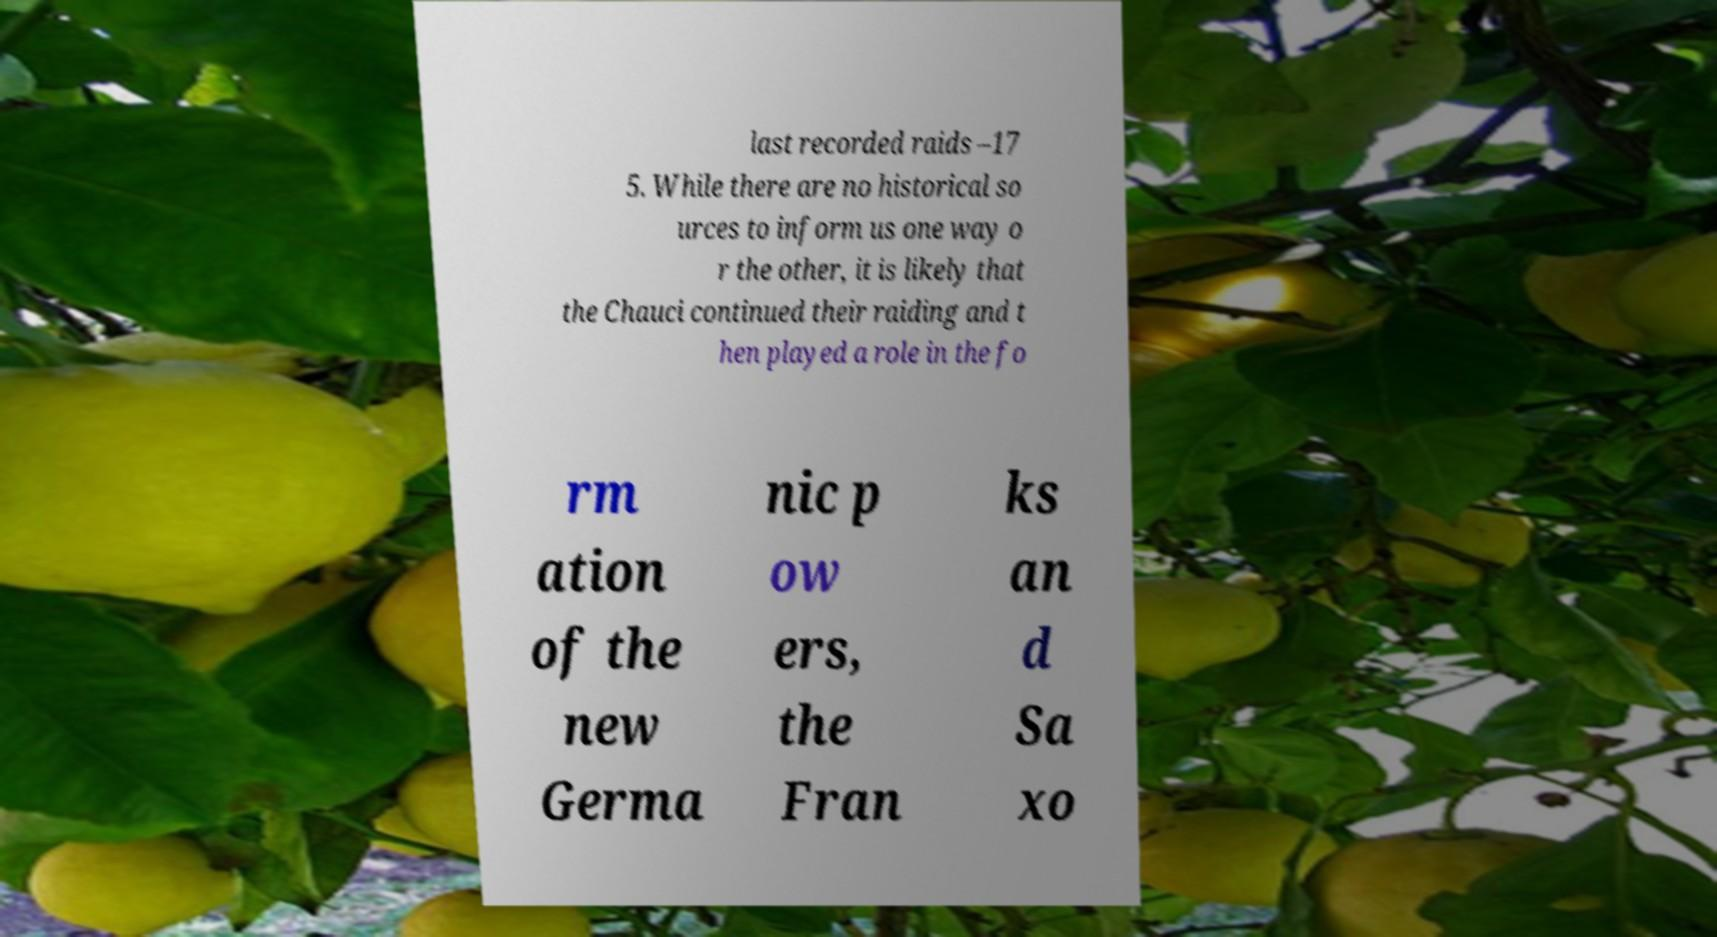What messages or text are displayed in this image? I need them in a readable, typed format. last recorded raids –17 5. While there are no historical so urces to inform us one way o r the other, it is likely that the Chauci continued their raiding and t hen played a role in the fo rm ation of the new Germa nic p ow ers, the Fran ks an d Sa xo 